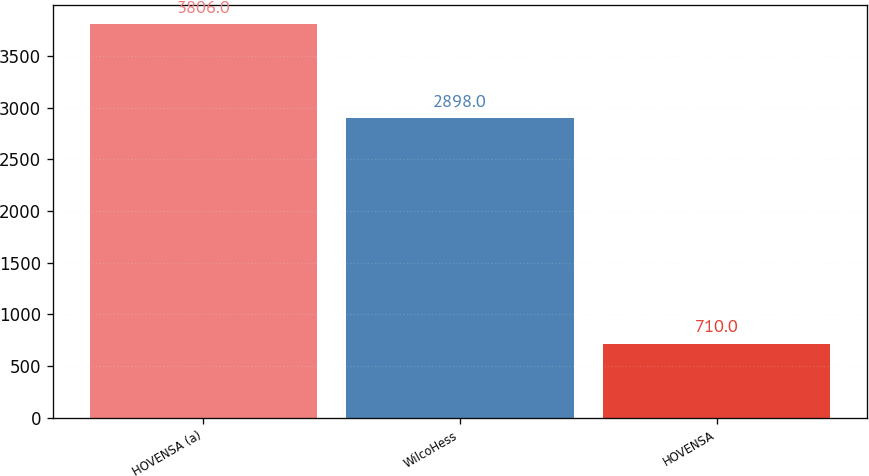Convert chart to OTSL. <chart><loc_0><loc_0><loc_500><loc_500><bar_chart><fcel>HOVENSA (a)<fcel>WilcoHess<fcel>HOVENSA<nl><fcel>3806<fcel>2898<fcel>710<nl></chart> 